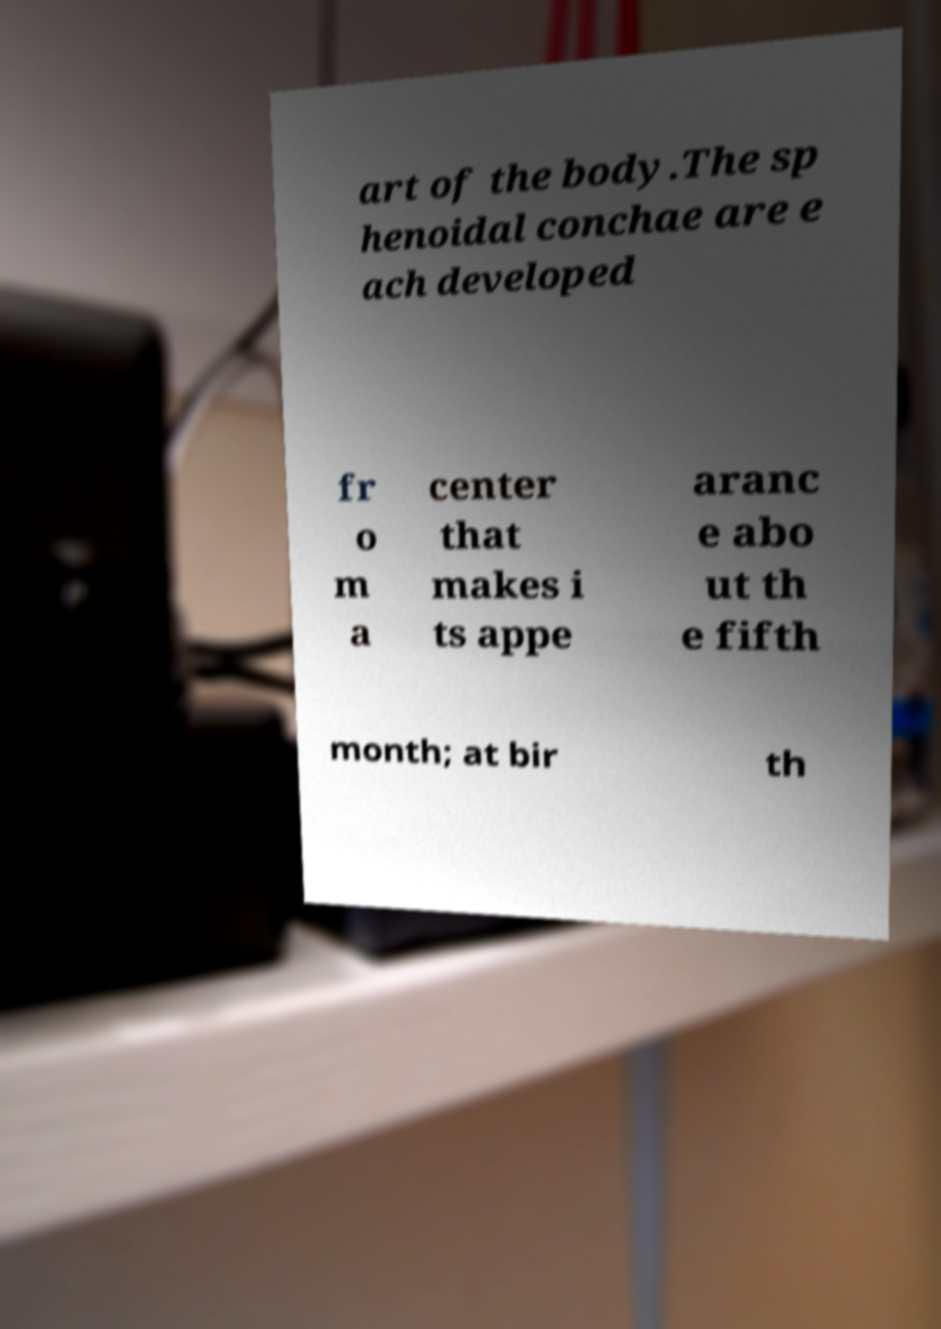I need the written content from this picture converted into text. Can you do that? art of the body.The sp henoidal conchae are e ach developed fr o m a center that makes i ts appe aranc e abo ut th e fifth month; at bir th 